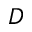<formula> <loc_0><loc_0><loc_500><loc_500>D</formula> 